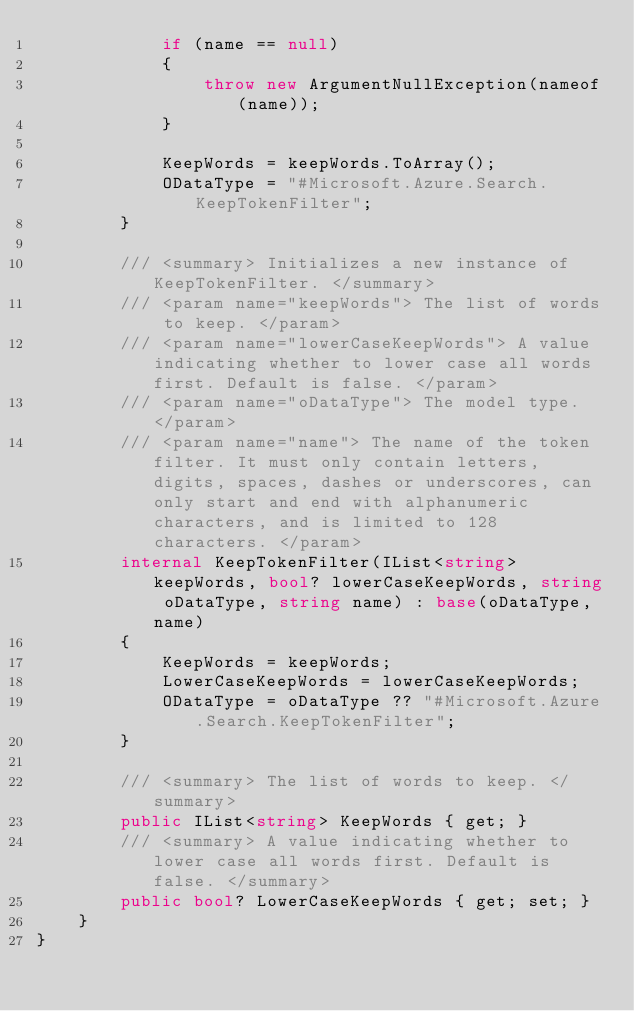<code> <loc_0><loc_0><loc_500><loc_500><_C#_>            if (name == null)
            {
                throw new ArgumentNullException(nameof(name));
            }

            KeepWords = keepWords.ToArray();
            ODataType = "#Microsoft.Azure.Search.KeepTokenFilter";
        }

        /// <summary> Initializes a new instance of KeepTokenFilter. </summary>
        /// <param name="keepWords"> The list of words to keep. </param>
        /// <param name="lowerCaseKeepWords"> A value indicating whether to lower case all words first. Default is false. </param>
        /// <param name="oDataType"> The model type. </param>
        /// <param name="name"> The name of the token filter. It must only contain letters, digits, spaces, dashes or underscores, can only start and end with alphanumeric characters, and is limited to 128 characters. </param>
        internal KeepTokenFilter(IList<string> keepWords, bool? lowerCaseKeepWords, string oDataType, string name) : base(oDataType, name)
        {
            KeepWords = keepWords;
            LowerCaseKeepWords = lowerCaseKeepWords;
            ODataType = oDataType ?? "#Microsoft.Azure.Search.KeepTokenFilter";
        }

        /// <summary> The list of words to keep. </summary>
        public IList<string> KeepWords { get; }
        /// <summary> A value indicating whether to lower case all words first. Default is false. </summary>
        public bool? LowerCaseKeepWords { get; set; }
    }
}
</code> 